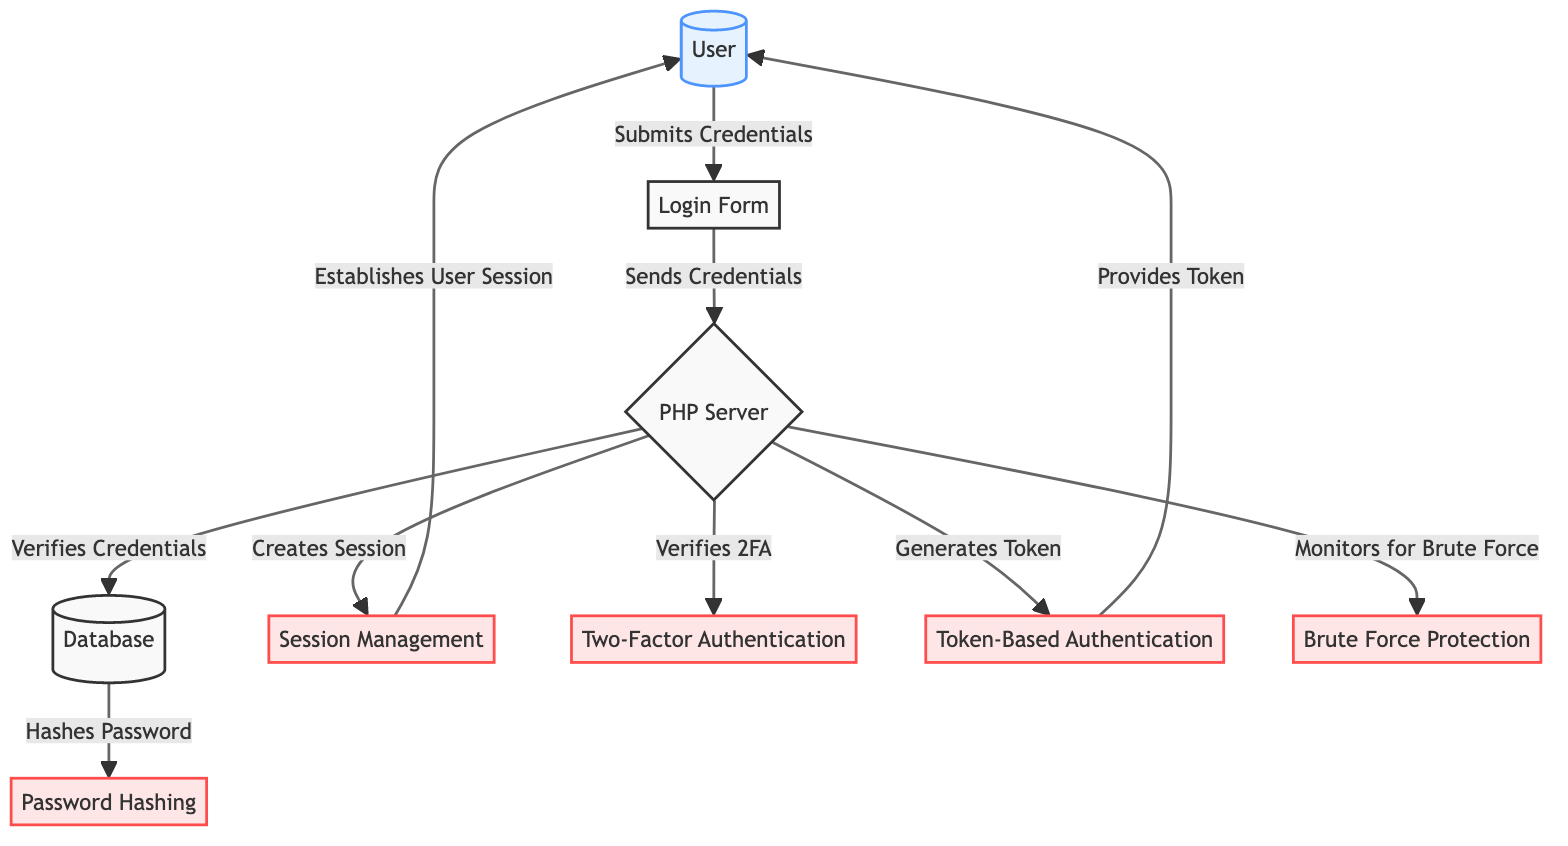What user action initiates the authentication process? The process starts when the user submits their credentials through the login form. This is indicated by the arrow pointing from the "User" node to the "Login Form" node labeled "Submits Credentials".
Answer: Submits Credentials How many security protocols are represented in the diagram? The diagram shows five security protocols, which are "Password Hashing", "Session Management", "Two-Factor Authentication", "Token-Based Authentication", and "Brute Force Protection". These are all indicated as security nodes in the diagram.
Answer: Five What component is responsible for verifying user credentials? The "PHP Server" is the component responsible for verifying user credentials as indicated by the connection from the "Login Form" to the "PHP Server" node labeled "Sends Credentials", which then connects to the "Database" to verify those credentials.
Answer: PHP Server Which action does the PHP Server take after verifying the credentials with the database? After verification, the PHP Server creates a session, as shown by the arrow from the "PHP Server" to the "Session Management" node labeled "Creates Session".
Answer: Creates Session What is the output provided to the user after successful token-based authentication? After successful token-based authentication, the output provided to the user is a token, as indicated by the connection from the "PHP Server" to the "Token-Based Authentication" node, which leads to "Provides Token" back to the user.
Answer: Provides Token Which security measure is continuously monitored by the PHP Server? The PHP Server monitors for brute force attacks as shown by the connection from the "PHP Server" to the "Brute Force Protection" node, labeled "Monitors for Brute Force".
Answer: Monitors for Brute Force What is the first action taken by the user in the authentication workflow? The first action taken by the user is to submit their credentials through the login form. This action is directly connected from the "User" to the "Login Form".
Answer: Submit Credentials What node is directly connected to the "Database" node? The "PHP Server" node is directly connected to the "Database" node as indicated by the arrow labeled "Verifies Credentials". This shows that the PHP Server interacts with the Database to validate user credentials.
Answer: PHP Server What security feature does the system implement in addition to standard authentication? In addition to standard authentication, the system implements Two-Factor Authentication as indicated by the "PHP Server" node's connection to the "Two-Factor Authentication" node for verifying the second factor.
Answer: Two-Factor Authentication 